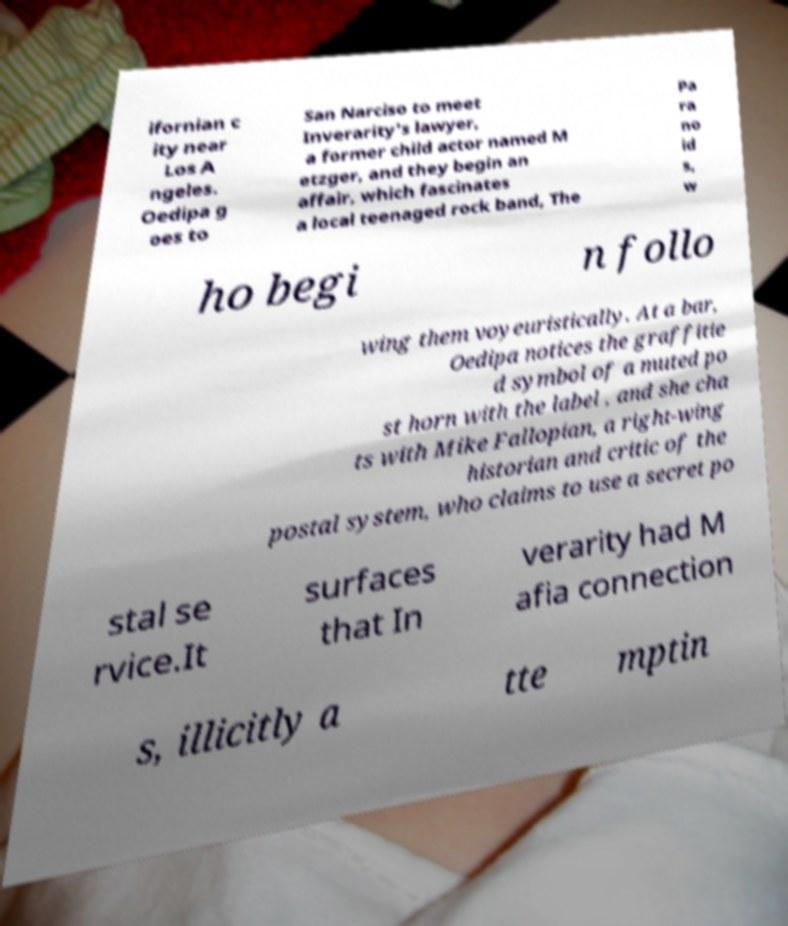I need the written content from this picture converted into text. Can you do that? ifornian c ity near Los A ngeles. Oedipa g oes to San Narciso to meet Inverarity's lawyer, a former child actor named M etzger, and they begin an affair, which fascinates a local teenaged rock band, The Pa ra no id s, w ho begi n follo wing them voyeuristically. At a bar, Oedipa notices the graffitie d symbol of a muted po st horn with the label , and she cha ts with Mike Fallopian, a right-wing historian and critic of the postal system, who claims to use a secret po stal se rvice.It surfaces that In verarity had M afia connection s, illicitly a tte mptin 